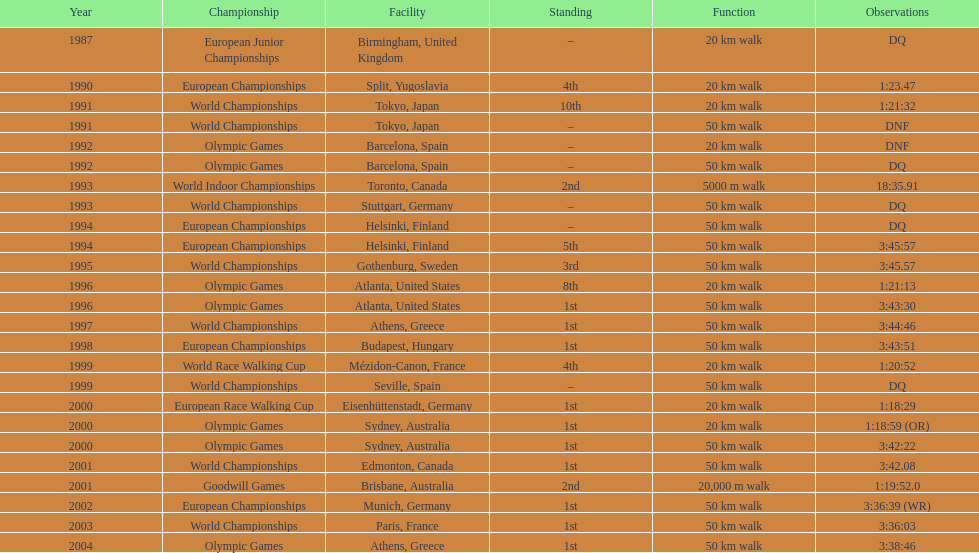How many times did korzeniowski finish above fourth place? 13. 